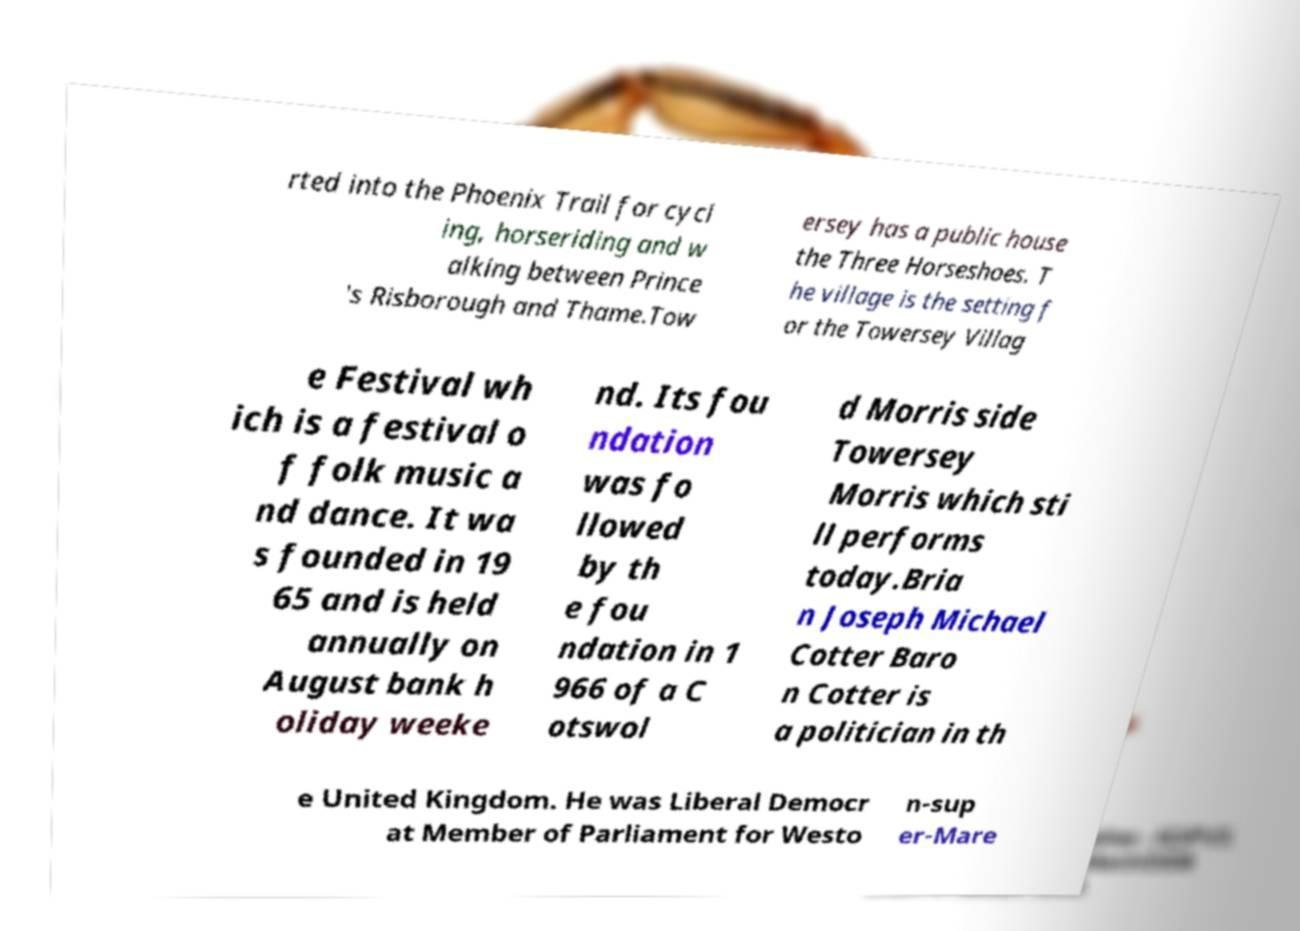Could you extract and type out the text from this image? rted into the Phoenix Trail for cycl ing, horseriding and w alking between Prince 's Risborough and Thame.Tow ersey has a public house the Three Horseshoes. T he village is the setting f or the Towersey Villag e Festival wh ich is a festival o f folk music a nd dance. It wa s founded in 19 65 and is held annually on August bank h oliday weeke nd. Its fou ndation was fo llowed by th e fou ndation in 1 966 of a C otswol d Morris side Towersey Morris which sti ll performs today.Bria n Joseph Michael Cotter Baro n Cotter is a politician in th e United Kingdom. He was Liberal Democr at Member of Parliament for Westo n-sup er-Mare 